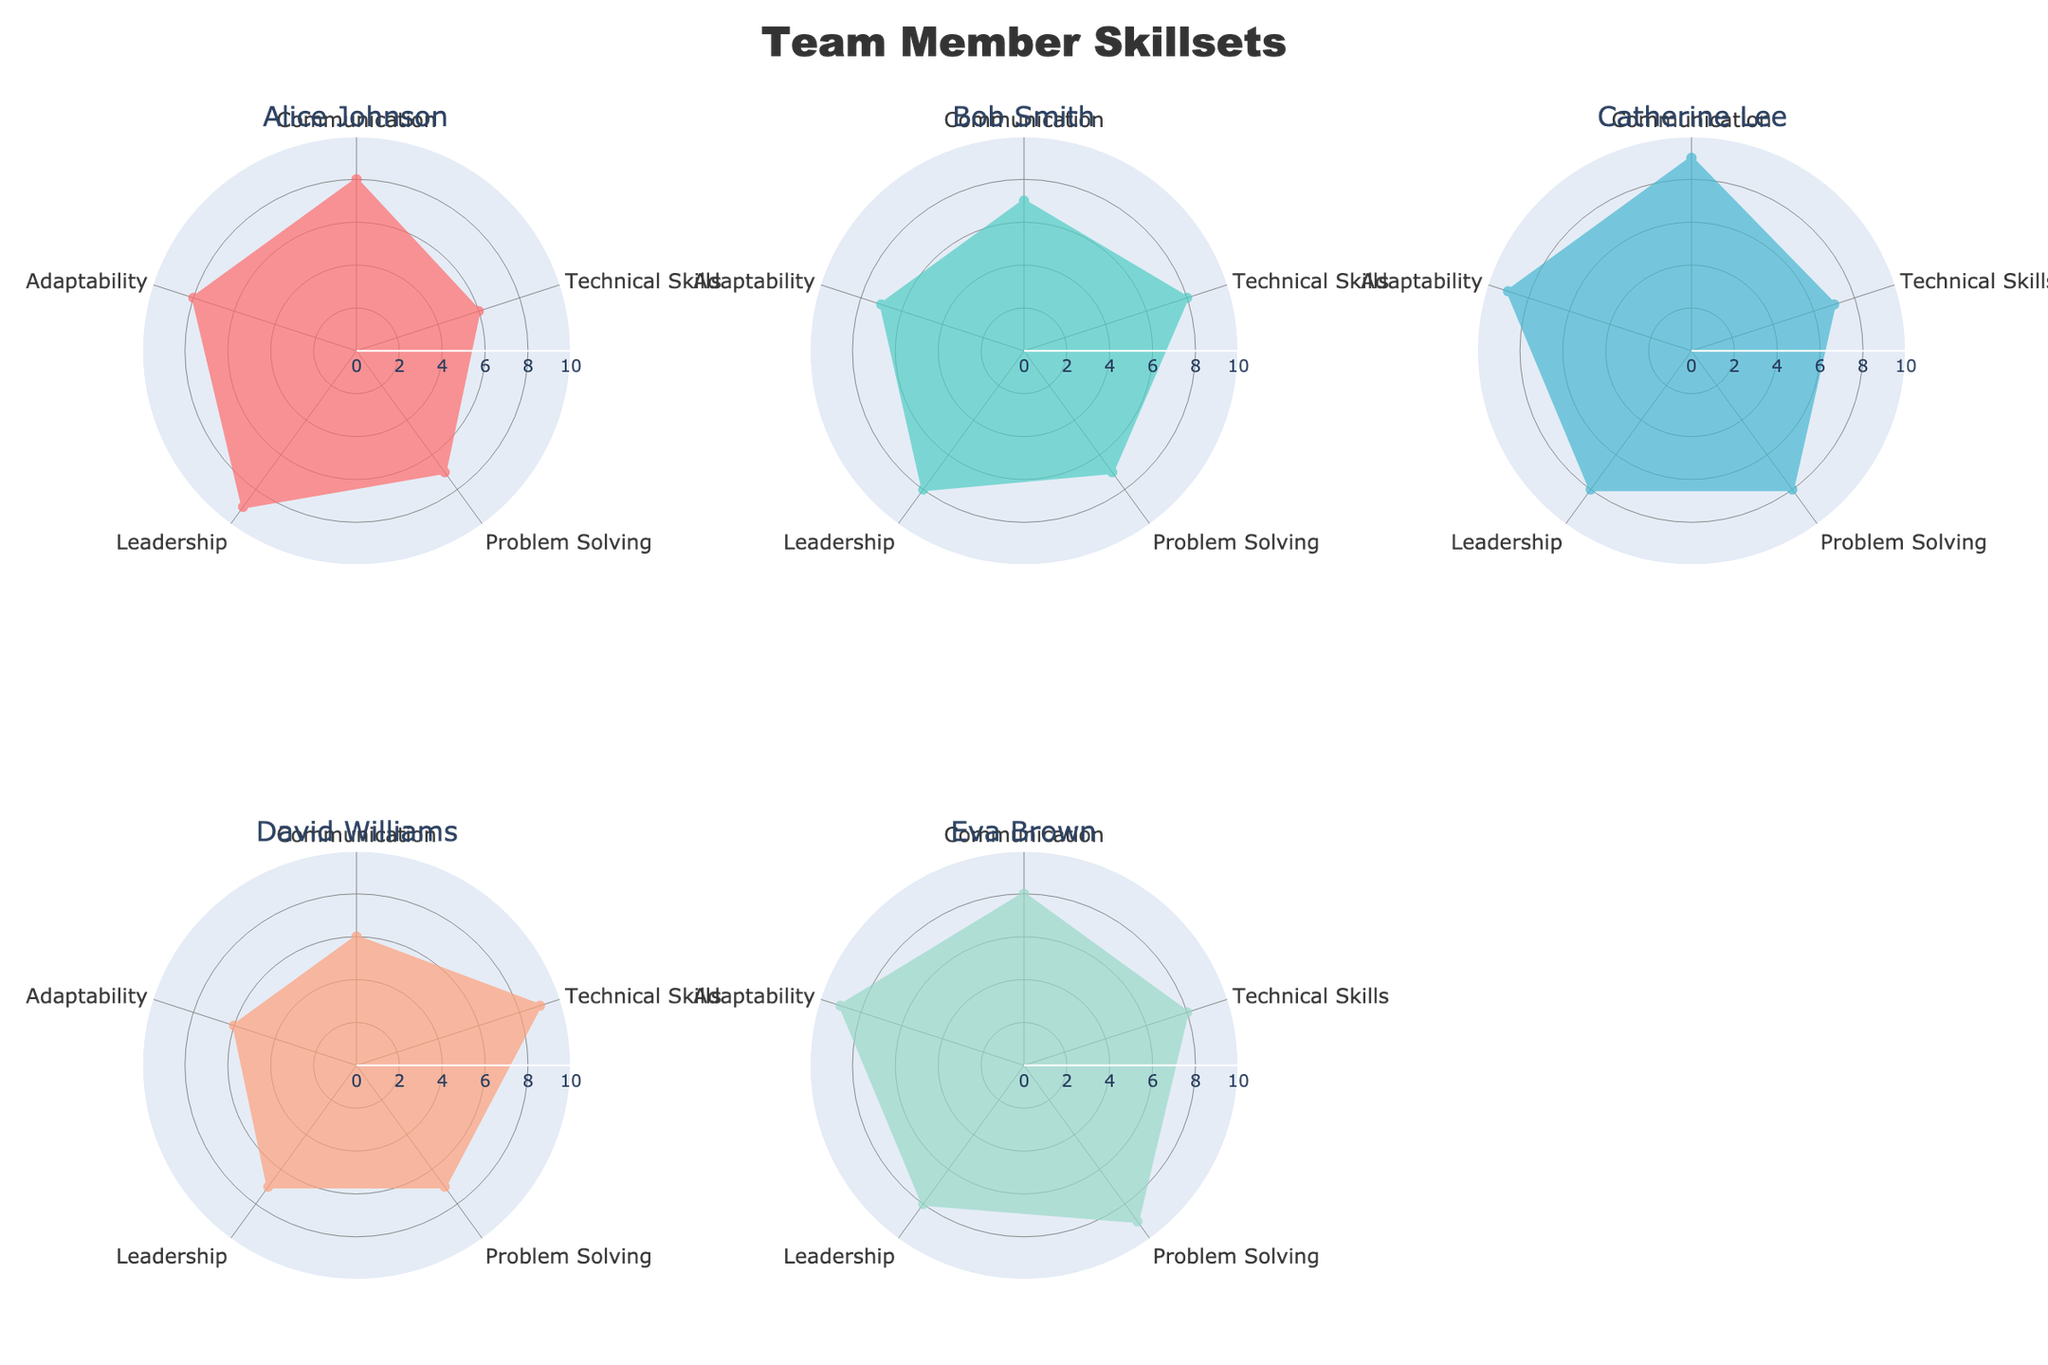Who has the highest competency level in Communication? By looking at the radar chart, the highest value on the Communication axis is 9, which is represented by Catherine Lee.
Answer: Catherine Lee Which team member shows the most balanced skill set across all competencies? A balanced skill set means having similar values across all axes in the radar chart. By observing the plots, Bob Smith and Eva Brown have the smallest deviations across categories. Upon closer inspection, Bob Smith has scores very close to each other ranging from 7 to 8.
Answer: Bob Smith What are the average levels of Adaptability across all team members? Summing the Adaptability scores for all team members (8 + 7 + 9 + 6 + 9) results in 39. There are 5 team members, so the average is 39/5.
Answer: 7.8 How do Alice Johnson and Eva Brown compare in terms of Problem Solving skills? By examining the radar plot, Alice Johnson has a Problem Solving score of 7, while Eva Brown has a score of 9. Eva outperforms Alice in this skill.
Answer: Eva Brown has higher Problem Solving skills than Alice Johnson Which team member needs the most improvement in Leadership? By looking at the radar chart and comparing the Leadership scores, the lowest value is 7, which belongs to both David Williams and Bob Smith.
Answer: David Williams and Bob Smith If we were to sum the Technical Skills of Alice Johnson, Bob Smith, and David Williams, what would it be? Adding up the Technical Skills for these three team members: Alice (6), Bob (8), and David (9) yields 6 + 8 + 9.
Answer: 23 Which competency shows the highest score for Catherine Lee and how does it compare to her lowest competency score? Catherine Lee has the highest score in Adaptability and Communication (both 9) as observed in the radar chart, and her lowest score is Technical Skills (7). Comparing these values indicates Adaptability and Communication are higher by 2 units than Technical Skills.
Answer: Adaptability and Communication are each 2 units higher than Technical Skills for Catherine Lee What is the range of Technical Skills scores among all team members? The minimum score in Technical Skills is 6 (Alice Johnson), and the maximum is 9 (David Williams). The range is calculated by subtracting the minimum from the maximum: 9 - 6.
Answer: 3 Is there any skill where all team members have the same rating? By examining each category in the radar charts, none of the skill ratings are the same for all team members.
Answer: No 